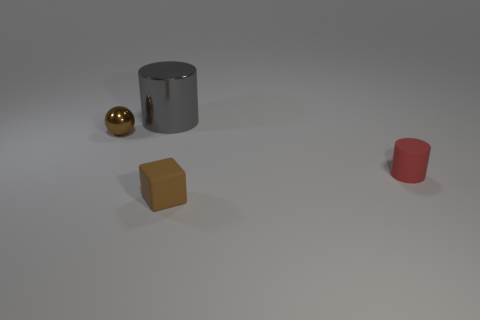There is a big gray thing that is made of the same material as the tiny brown ball; what is its shape?
Your answer should be compact. Cylinder. Is there any other thing of the same color as the large metal thing?
Ensure brevity in your answer.  No. There is a matte block that is the same color as the tiny metal sphere; what size is it?
Provide a succinct answer. Small. Is the number of tiny red cylinders that are behind the brown cube greater than the number of gray cylinders?
Your response must be concise. No. Does the tiny shiny thing have the same shape as the tiny matte thing left of the red rubber object?
Your answer should be compact. No. How many yellow cylinders have the same size as the brown ball?
Keep it short and to the point. 0. How many small things are behind the tiny brown object to the right of the metallic thing on the right side of the small brown ball?
Give a very brief answer. 2. Are there the same number of big metal objects that are left of the gray object and big metal cylinders in front of the small brown shiny ball?
Give a very brief answer. Yes. What number of large gray metallic things have the same shape as the brown metallic thing?
Offer a terse response. 0. Is there a tiny blue cube that has the same material as the brown ball?
Give a very brief answer. No. 